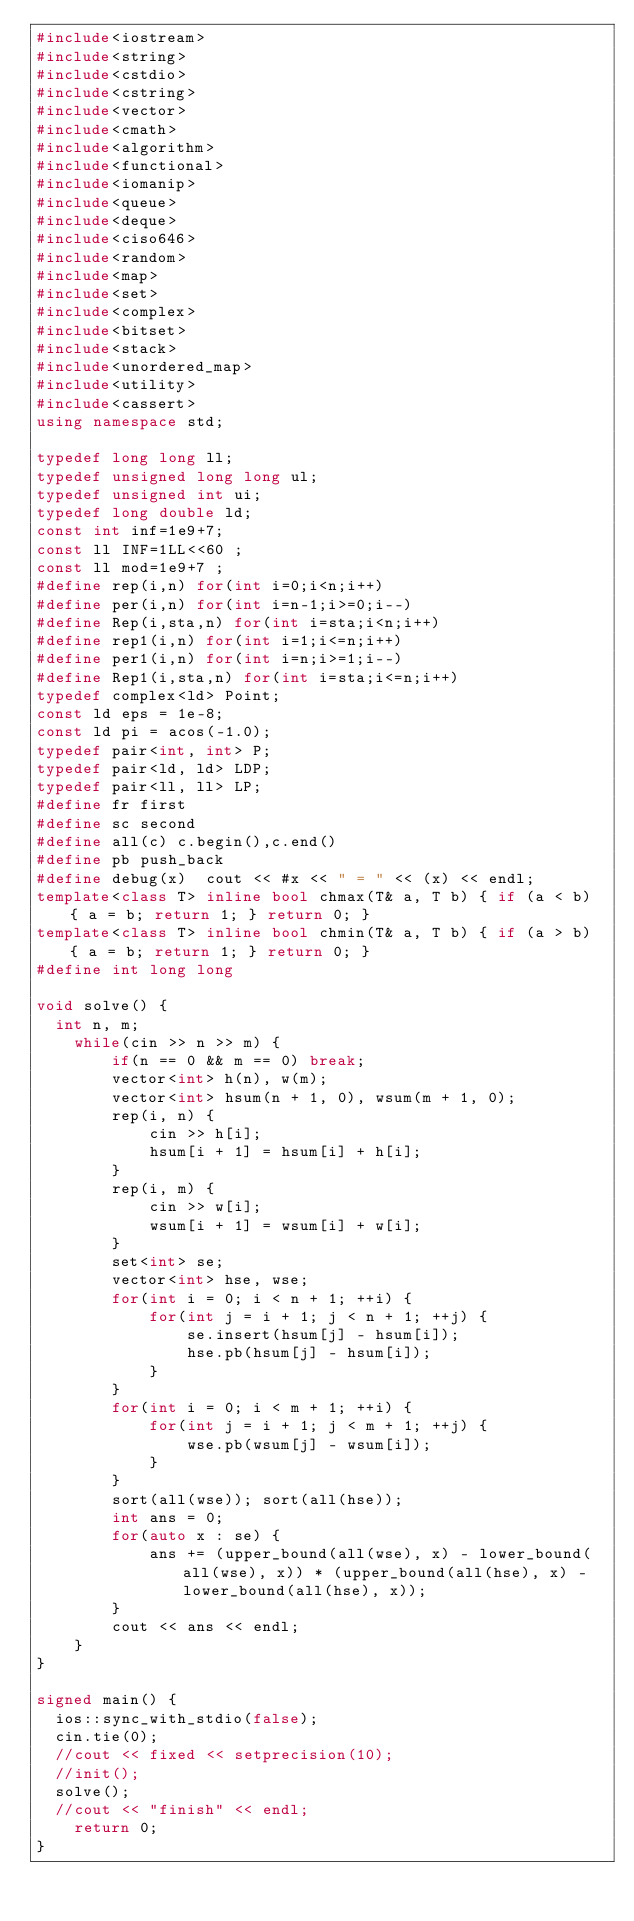Convert code to text. <code><loc_0><loc_0><loc_500><loc_500><_C++_>#include<iostream>
#include<string>
#include<cstdio>
#include<cstring>
#include<vector>
#include<cmath>
#include<algorithm>
#include<functional>
#include<iomanip>
#include<queue>
#include<deque>
#include<ciso646>
#include<random>
#include<map>
#include<set>
#include<complex>
#include<bitset>
#include<stack>
#include<unordered_map>
#include<utility>
#include<cassert>
using namespace std;

typedef long long ll;
typedef unsigned long long ul;
typedef unsigned int ui;
typedef long double ld;
const int inf=1e9+7;
const ll INF=1LL<<60 ;
const ll mod=1e9+7 ;
#define rep(i,n) for(int i=0;i<n;i++)
#define per(i,n) for(int i=n-1;i>=0;i--)
#define Rep(i,sta,n) for(int i=sta;i<n;i++)
#define rep1(i,n) for(int i=1;i<=n;i++)
#define per1(i,n) for(int i=n;i>=1;i--)
#define Rep1(i,sta,n) for(int i=sta;i<=n;i++)
typedef complex<ld> Point;
const ld eps = 1e-8;
const ld pi = acos(-1.0);
typedef pair<int, int> P;
typedef pair<ld, ld> LDP;
typedef pair<ll, ll> LP;
#define fr first
#define sc second
#define all(c) c.begin(),c.end()
#define pb push_back
#define debug(x)  cout << #x << " = " << (x) << endl;
template<class T> inline bool chmax(T& a, T b) { if (a < b) { a = b; return 1; } return 0; }
template<class T> inline bool chmin(T& a, T b) { if (a > b) { a = b; return 1; } return 0; }
#define int long long

void solve() {
	int n, m;
    while(cin >> n >> m) {
        if(n == 0 && m == 0) break;
        vector<int> h(n), w(m);
        vector<int> hsum(n + 1, 0), wsum(m + 1, 0);
        rep(i, n) {
            cin >> h[i];
            hsum[i + 1] = hsum[i] + h[i];
        }
        rep(i, m) {
            cin >> w[i];
            wsum[i + 1] = wsum[i] + w[i];
        }
        set<int> se;
        vector<int> hse, wse;
        for(int i = 0; i < n + 1; ++i) {
            for(int j = i + 1; j < n + 1; ++j) {
                se.insert(hsum[j] - hsum[i]);
                hse.pb(hsum[j] - hsum[i]);
            }
        }
        for(int i = 0; i < m + 1; ++i) {
            for(int j = i + 1; j < m + 1; ++j) {
                wse.pb(wsum[j] - wsum[i]);
            }
        }
        sort(all(wse)); sort(all(hse));
        int ans = 0;
        for(auto x : se) {
            ans += (upper_bound(all(wse), x) - lower_bound(all(wse), x)) * (upper_bound(all(hse), x) - lower_bound(all(hse), x));
        }
        cout << ans << endl;
    }
}

signed main() {
	ios::sync_with_stdio(false);
	cin.tie(0);
	//cout << fixed << setprecision(10);
	//init();
	solve();
	//cout << "finish" << endl;
    return 0;
}
</code> 